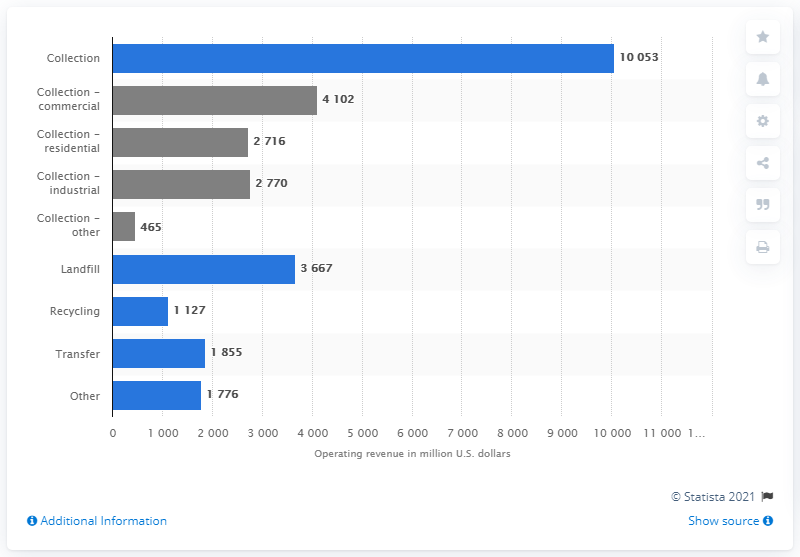List a handful of essential elements in this visual. Waste Management Inc's commercial collection services generated a certain amount of money in 4102. In 2020, Waste Management Inc's operating revenue was approximately $10,053 million. 